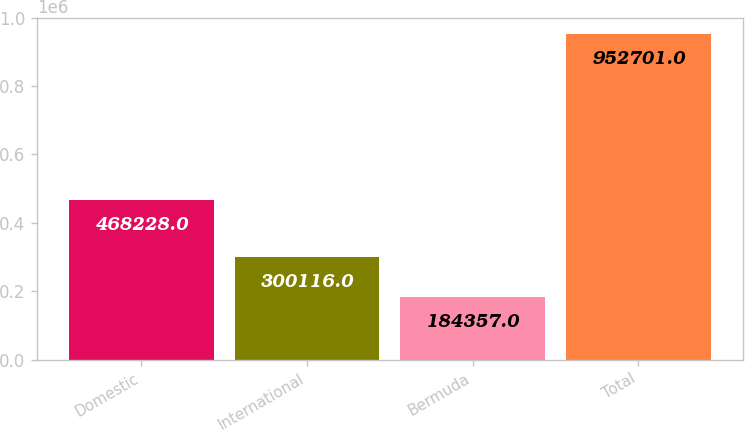Convert chart to OTSL. <chart><loc_0><loc_0><loc_500><loc_500><bar_chart><fcel>Domestic<fcel>International<fcel>Bermuda<fcel>Total<nl><fcel>468228<fcel>300116<fcel>184357<fcel>952701<nl></chart> 